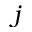Convert formula to latex. <formula><loc_0><loc_0><loc_500><loc_500>j</formula> 